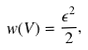Convert formula to latex. <formula><loc_0><loc_0><loc_500><loc_500>w ( V ) = \frac { \epsilon ^ { 2 } } { 2 } ,</formula> 